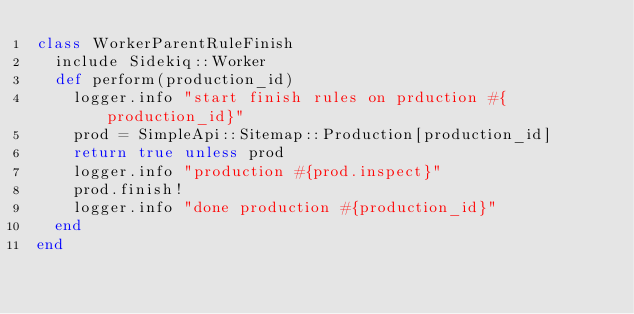Convert code to text. <code><loc_0><loc_0><loc_500><loc_500><_Ruby_>class WorkerParentRuleFinish
  include Sidekiq::Worker
  def perform(production_id)
    logger.info "start finish rules on prduction #{production_id}"
    prod = SimpleApi::Sitemap::Production[production_id]
    return true unless prod
    logger.info "production #{prod.inspect}"
    prod.finish!
    logger.info "done production #{production_id}"
  end
end
</code> 